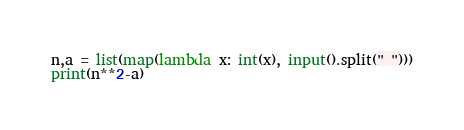<code> <loc_0><loc_0><loc_500><loc_500><_Python_>n,a = list(map(lambda x: int(x), input().split(" ")))
print(n**2-a)</code> 